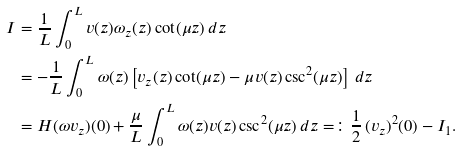Convert formula to latex. <formula><loc_0><loc_0><loc_500><loc_500>I & = \frac { 1 } { L } \int _ { 0 } ^ { L } v ( z ) \omega _ { z } ( z ) \cot ( \mu z ) \, d z \\ & = - \frac { 1 } { L } \int _ { 0 } ^ { L } \omega ( z ) \left [ v _ { z } ( z ) \cot ( \mu z ) - \mu v ( z ) \csc ^ { 2 } ( \mu z ) \right ] \, d z \\ & = H ( \omega v _ { z } ) ( 0 ) + \frac { \mu } { L } \int _ { 0 } ^ { L } \omega ( z ) v ( z ) \csc ^ { 2 } ( \mu z ) \, d z = \colon \frac { 1 } { 2 } \, ( v _ { z } ) ^ { 2 } ( 0 ) - I _ { 1 } .</formula> 